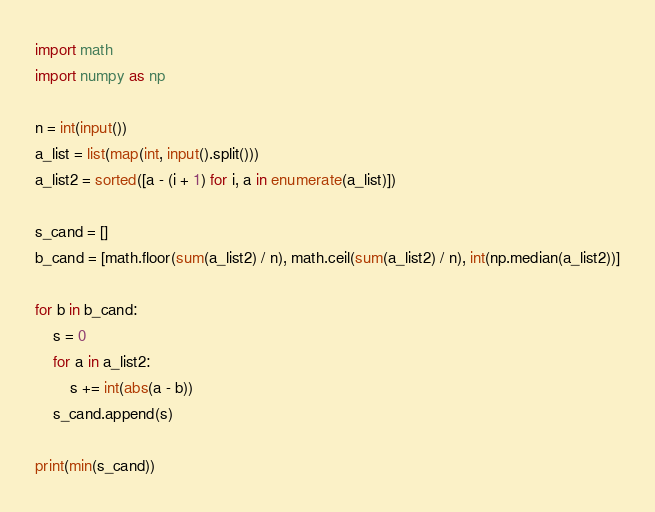Convert code to text. <code><loc_0><loc_0><loc_500><loc_500><_Python_>import math
import numpy as np

n = int(input())
a_list = list(map(int, input().split()))
a_list2 = sorted([a - (i + 1) for i, a in enumerate(a_list)])

s_cand = []
b_cand = [math.floor(sum(a_list2) / n), math.ceil(sum(a_list2) / n), int(np.median(a_list2))]

for b in b_cand:
    s = 0
    for a in a_list2:
        s += int(abs(a - b))
    s_cand.append(s)
    
print(min(s_cand))</code> 